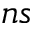<formula> <loc_0><loc_0><loc_500><loc_500>n s</formula> 